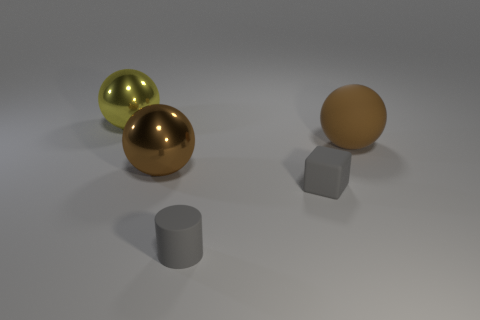Does the large metallic object in front of the large matte ball have the same color as the small rubber block?
Make the answer very short. No. What number of objects are behind the cylinder and in front of the big yellow sphere?
Provide a succinct answer. 3. There is a brown metal thing that is the same shape as the big rubber thing; what size is it?
Give a very brief answer. Large. What number of yellow metallic objects are on the right side of the rubber object behind the metal object in front of the big brown matte ball?
Make the answer very short. 0. The large sphere that is on the right side of the big metallic thing to the right of the yellow shiny object is what color?
Provide a succinct answer. Brown. What number of other things are there of the same material as the small cylinder
Offer a very short reply. 2. What number of large spheres are on the right side of the shiny object that is in front of the brown rubber thing?
Make the answer very short. 1. Are there any other things that have the same shape as the yellow thing?
Offer a very short reply. Yes. Is the color of the ball on the left side of the brown shiny ball the same as the large metal ball that is right of the yellow ball?
Your answer should be compact. No. Is the number of tiny gray metallic objects less than the number of large rubber things?
Give a very brief answer. Yes. 